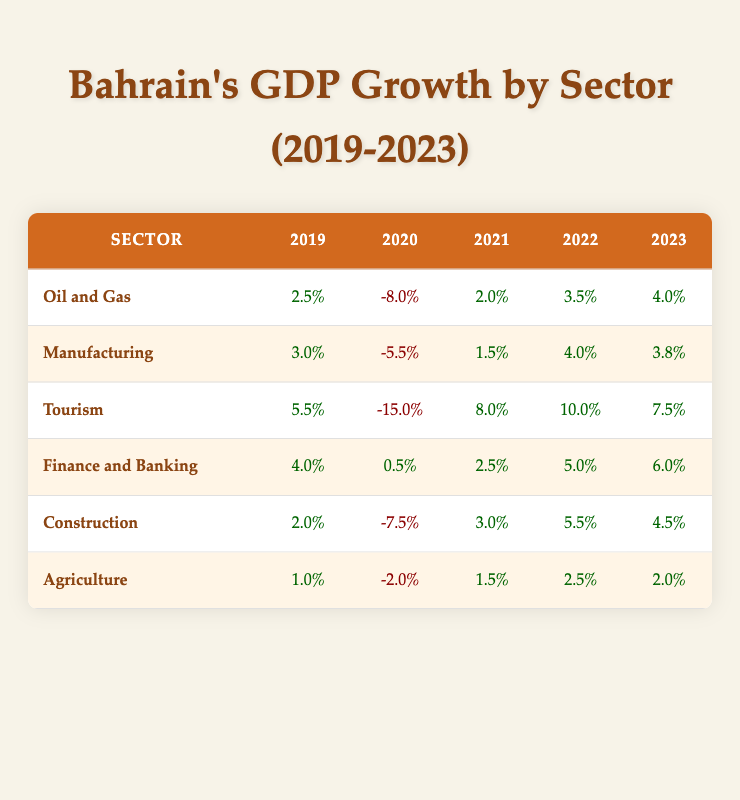What was the GDP growth rate for the Tourism sector in 2022? According to the table, the GDP growth rate for the Tourism sector in 2022 is explicitly listed as 10.0%.
Answer: 10.0% What is the difference in GDP growth rate for Oil and Gas between 2020 and 2023? The GDP growth rate for Oil and Gas in 2020 is -8.0% while in 2023 it is 4.0%. The difference is calculated as 4.0% - (-8.0%) = 4.0% + 8.0% = 12.0%.
Answer: 12.0% Did the Agriculture sector have a positive GDP growth rate in 2021? Yes, the Agriculture sector's GDP growth rate in 2021 is 1.5%, which is a positive value.
Answer: Yes Which sector experienced the largest decline in GDP growth during 2020? By examining the data, the sector with the largest decline in 2020 is Tourism, with a GDP growth rate of -15.0%.
Answer: Tourism What is the average GDP growth rate for the Finance and Banking sector from 2019 to 2023? The growth rates for Finance and Banking from 2019 to 2023 are: 4.0%, 0.5%, 2.5%, 5.0%, and 6.0%. The sum is 4.0 + 0.5 + 2.5 + 5.0 + 6.0 = 18.0%, and there are 5 data points. Dividing gives an average of 18.0% / 5 = 3.6%.
Answer: 3.6% What was the highest GDP growth rate achieved by the Manufacturing sector, and in which year did it occur? The highest GDP growth rate for the Manufacturing sector is 4.0%, which occurred in 2022.
Answer: 4.0% in 2022 Which sector had a consistent increase in GDP growth from 2021 to 2023? By looking at the table, the Finance and Banking sector shows a consistent increase from 2.5% in 2021 to 6.0% in 2023.
Answer: Finance and Banking What was the total GDP growth rate from all sectors for 2022? To find the total GDP growth rate for 2022, we need to add up all the individual sector growth rates: 3.5% (Oil and Gas) + 4.0% (Manufacturing) + 10.0% (Tourism) + 5.0% (Finance and Banking) + 5.5% (Construction) + 2.5% (Agriculture) = 30.5%.
Answer: 30.5% 